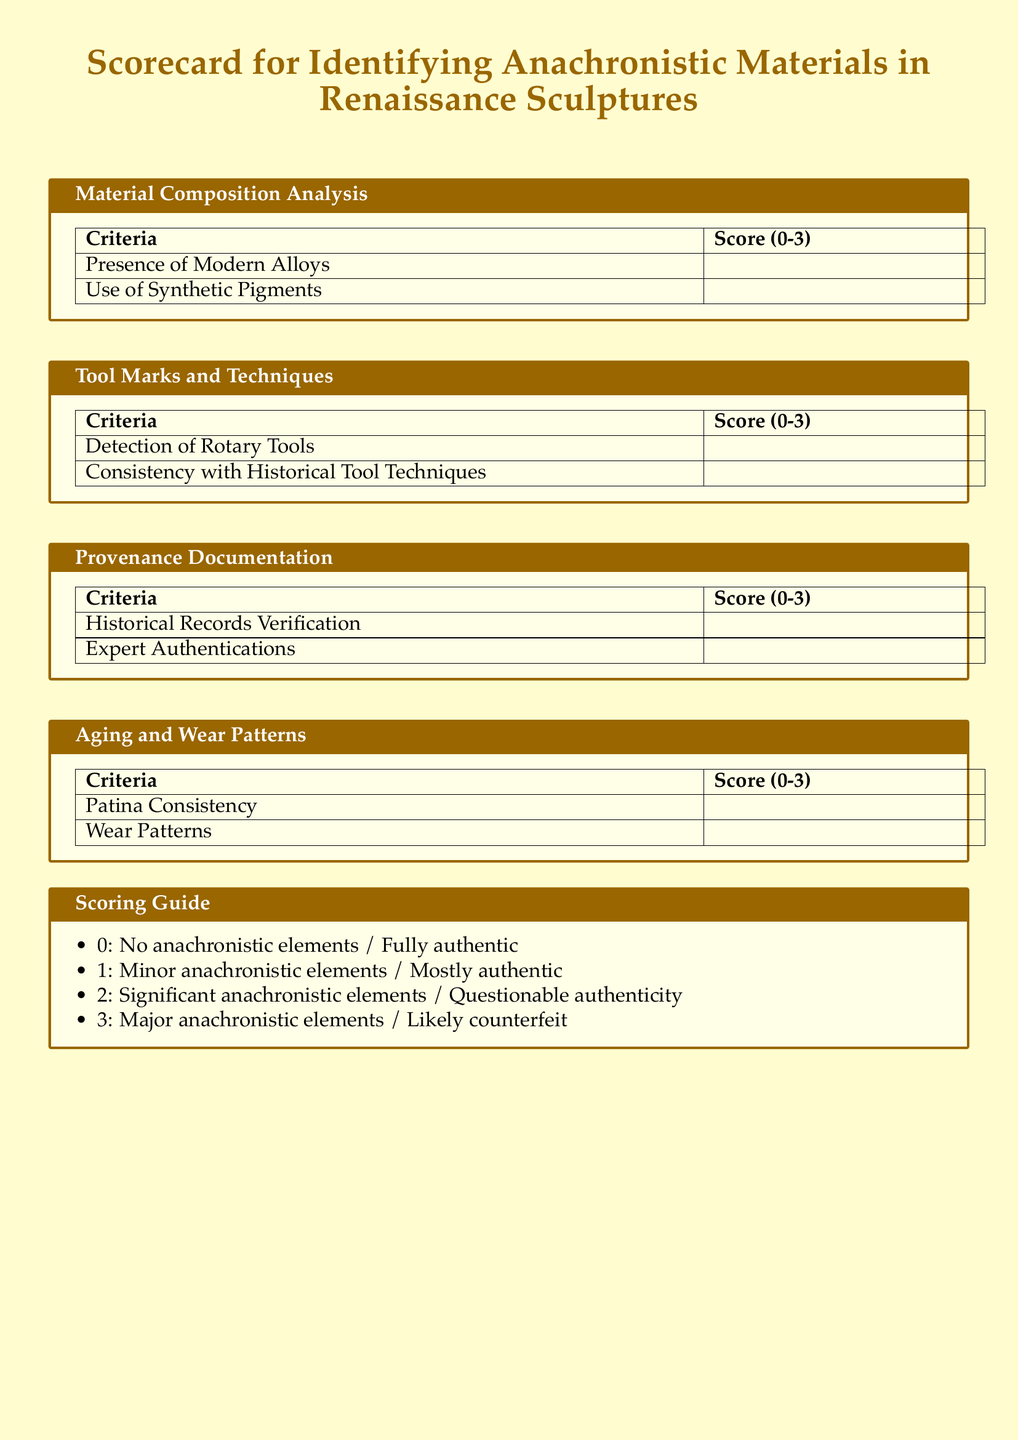What is the title of the document? The title of the document is prominently displayed at the top of the page.
Answer: Scorecard for Identifying Anachronistic Materials in Renaissance Sculptures What scoring range is used in the scoring guide? The scoring guide lists a range of scores for evaluating authenticity from 0 to 3.
Answer: 0-3 How many main sections are included in the scorecard? The scorecard includes four main sections for analysis of different criteria.
Answer: Four What criterion is assessed under the section "Material Composition Analysis"? One of the criteria assessed is the "Presence of Modern Alloys."
Answer: Presence of Modern Alloys What does a score of 2 indicate in the scoring guide? The scoring guide describes a score of 2 as having significant anachronistic elements.
Answer: Significant anachronistic elements / Questionable authenticity Which section includes "Detection of Rotary Tools"? This criterion is included in the section focused on analyzing tools and techniques used.
Answer: Tool Marks and Techniques What visual color is associated with the document's theme? The document uses a specific color displayed in various elements to enhance its thematic presentation.
Answer: Renaissance Which criterion relates to patina in the scorecard? The scorecard assesses "Patina Consistency" as a criterion under aging and wear analysis.
Answer: Patina Consistency 